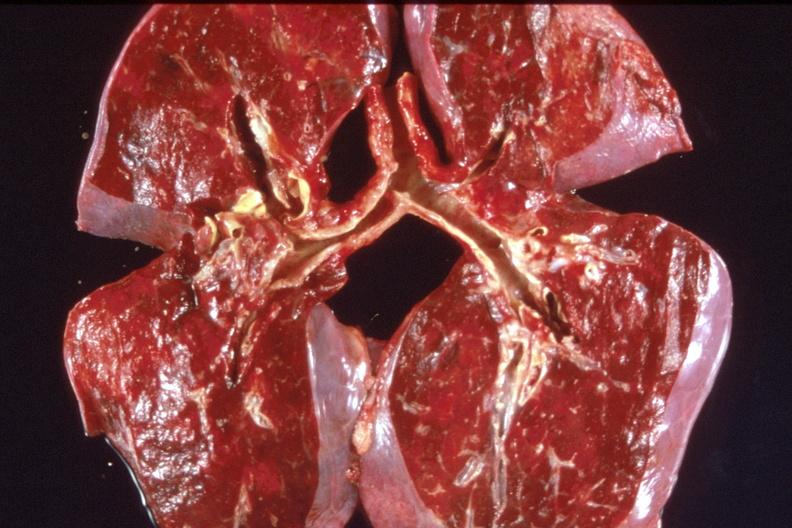what is present?
Answer the question using a single word or phrase. Respiratory 